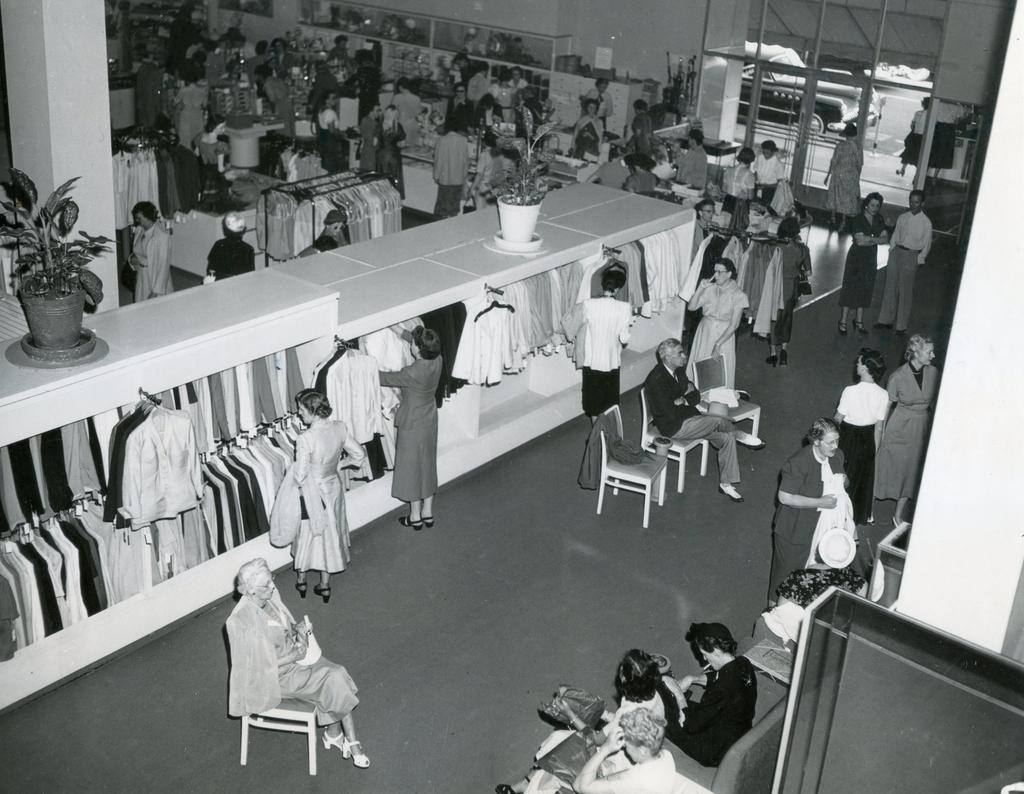Could you give a brief overview of what you see in this image? This is a black and white image. We can see inside view of a building. There are chairs, clothes people and some objects. On the left side of the image, there is a pillar and there are house plants on the platform. In the top right corner of the image, there are glass doors and a vehicle. 